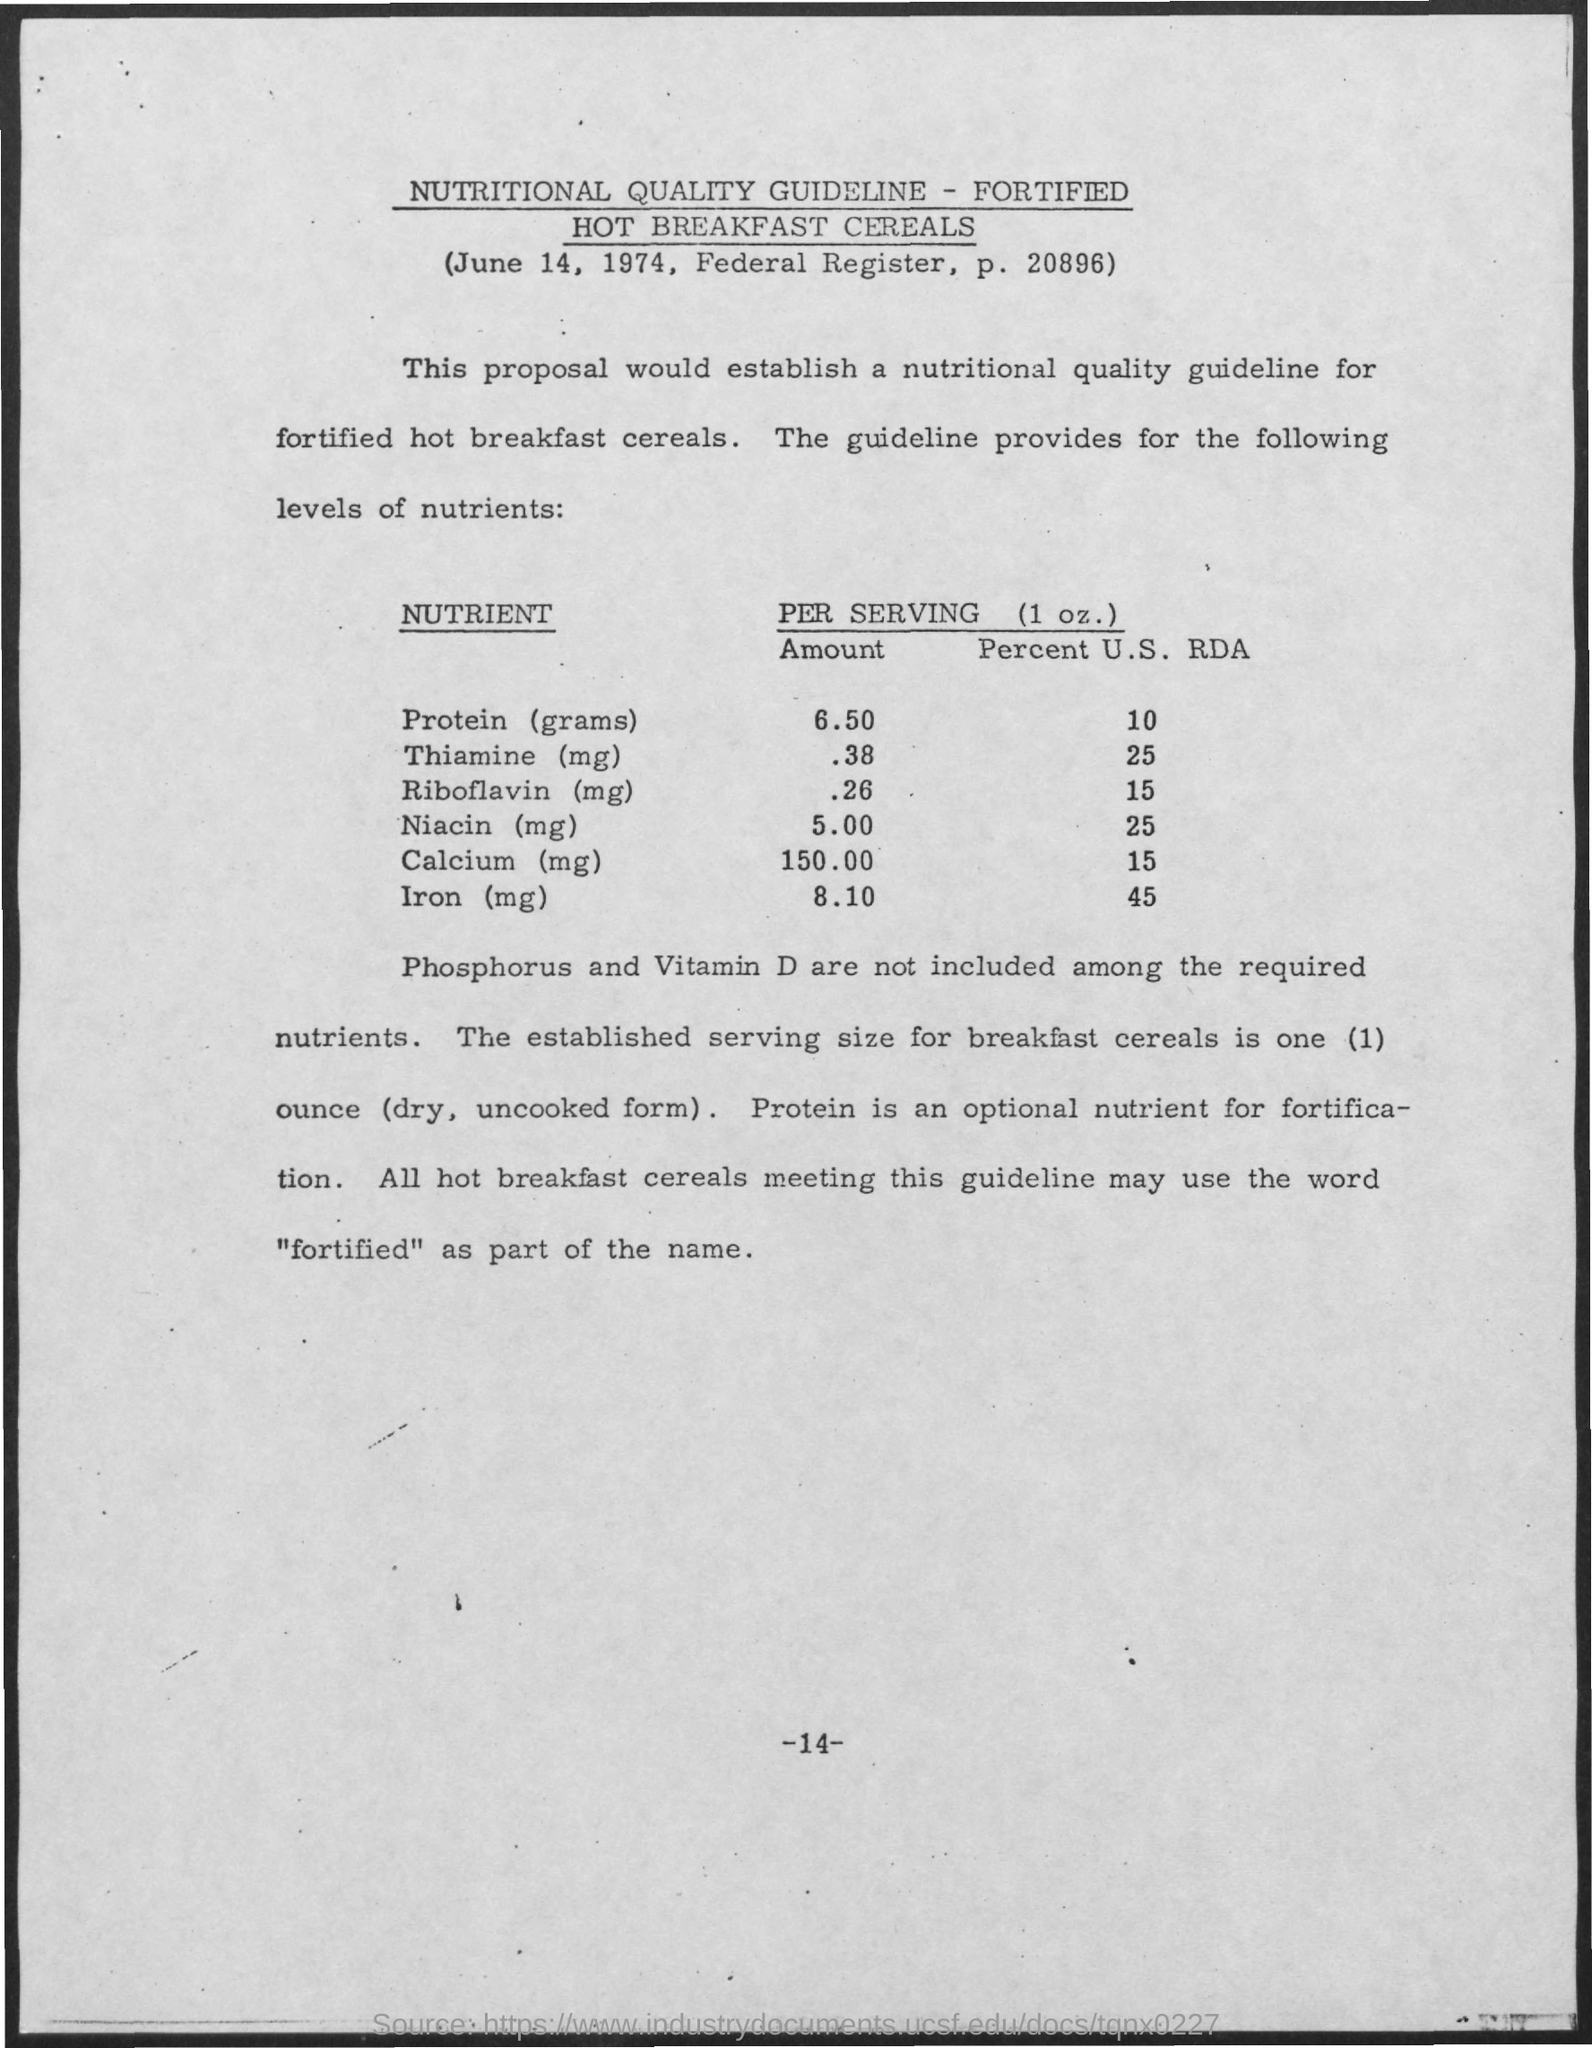What is the Date?
Offer a terse response. June 14, 1974. The proposal would establish a nutritional quality guideline for what?
Your response must be concise. Fortified hot breakfast cereals. 